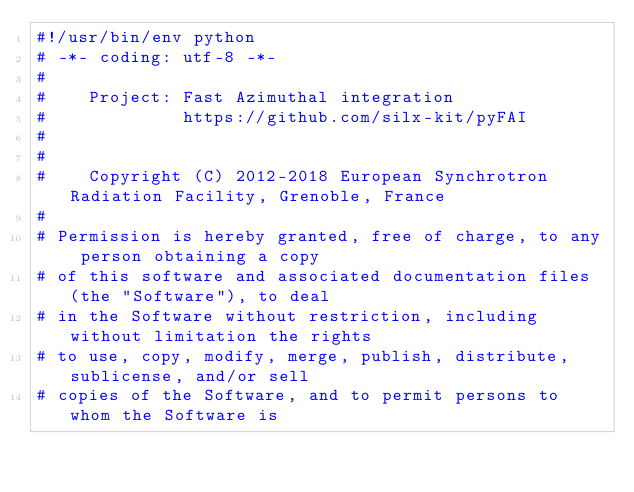Convert code to text. <code><loc_0><loc_0><loc_500><loc_500><_Cython_>#!/usr/bin/env python
# -*- coding: utf-8 -*-
#
#    Project: Fast Azimuthal integration
#             https://github.com/silx-kit/pyFAI
#
#
#    Copyright (C) 2012-2018 European Synchrotron Radiation Facility, Grenoble, France
#
# Permission is hereby granted, free of charge, to any person obtaining a copy
# of this software and associated documentation files (the "Software"), to deal
# in the Software without restriction, including without limitation the rights
# to use, copy, modify, merge, publish, distribute, sublicense, and/or sell
# copies of the Software, and to permit persons to whom the Software is</code> 